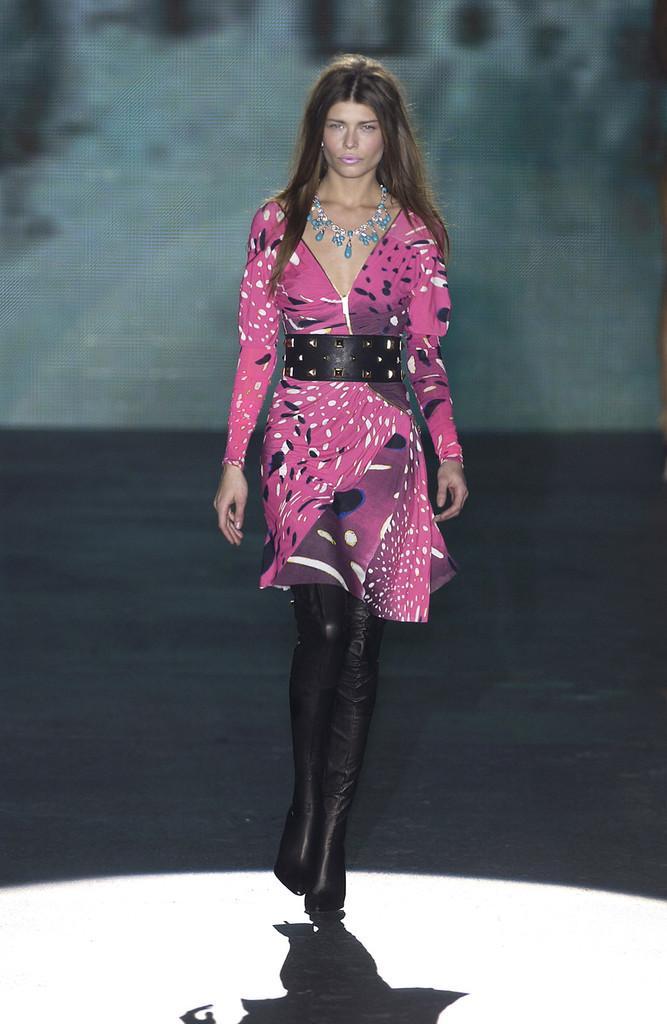Could you give a brief overview of what you see in this image? In the center of the image there is a woman walking on the floor. 